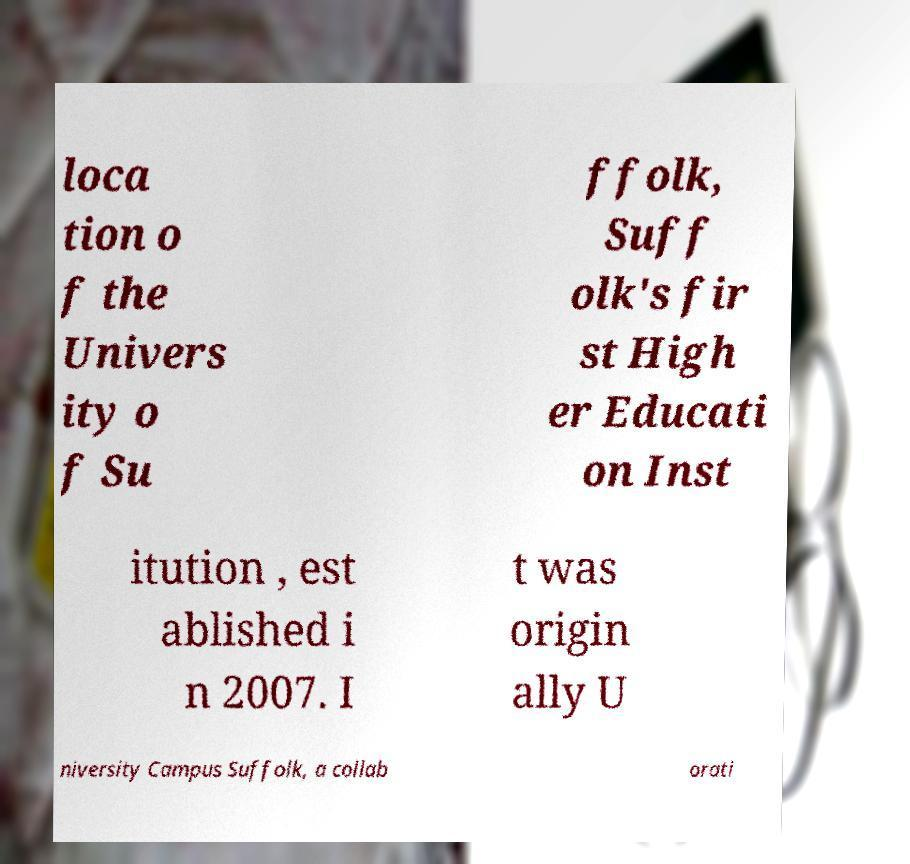Can you read and provide the text displayed in the image?This photo seems to have some interesting text. Can you extract and type it out for me? loca tion o f the Univers ity o f Su ffolk, Suff olk's fir st High er Educati on Inst itution , est ablished i n 2007. I t was origin ally U niversity Campus Suffolk, a collab orati 